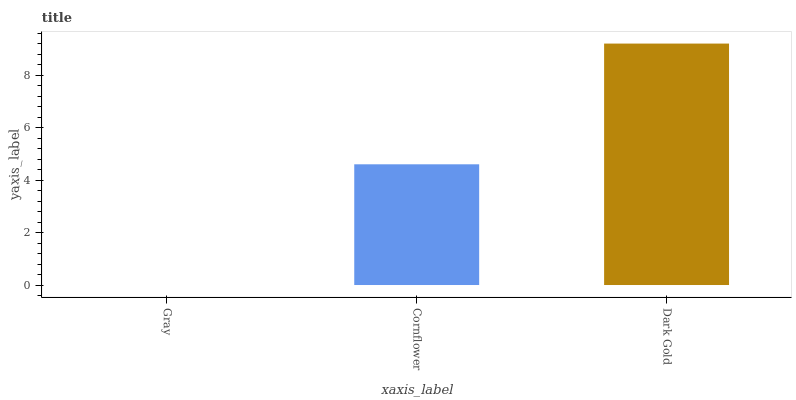Is Gray the minimum?
Answer yes or no. Yes. Is Dark Gold the maximum?
Answer yes or no. Yes. Is Cornflower the minimum?
Answer yes or no. No. Is Cornflower the maximum?
Answer yes or no. No. Is Cornflower greater than Gray?
Answer yes or no. Yes. Is Gray less than Cornflower?
Answer yes or no. Yes. Is Gray greater than Cornflower?
Answer yes or no. No. Is Cornflower less than Gray?
Answer yes or no. No. Is Cornflower the high median?
Answer yes or no. Yes. Is Cornflower the low median?
Answer yes or no. Yes. Is Dark Gold the high median?
Answer yes or no. No. Is Gray the low median?
Answer yes or no. No. 